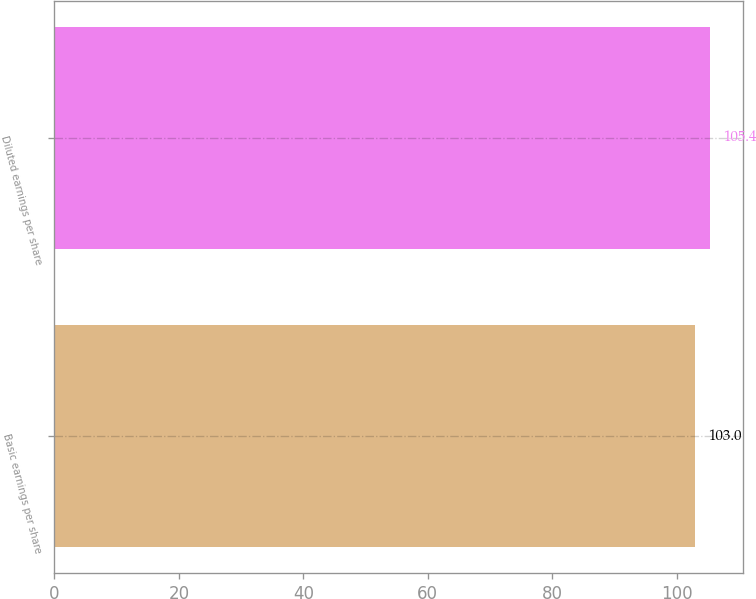<chart> <loc_0><loc_0><loc_500><loc_500><bar_chart><fcel>Basic earnings per share<fcel>Diluted earnings per share<nl><fcel>103<fcel>105.4<nl></chart> 